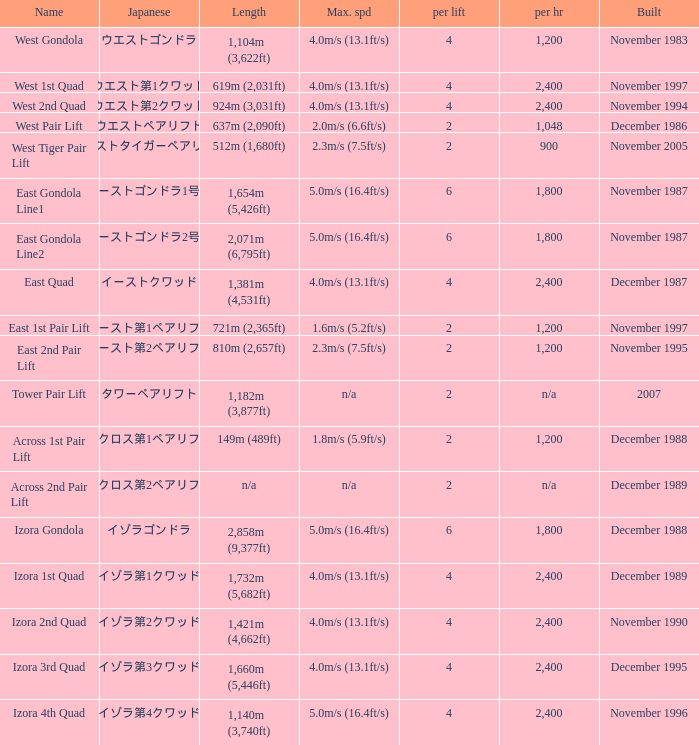How heavy is the  maximum 6.0. 